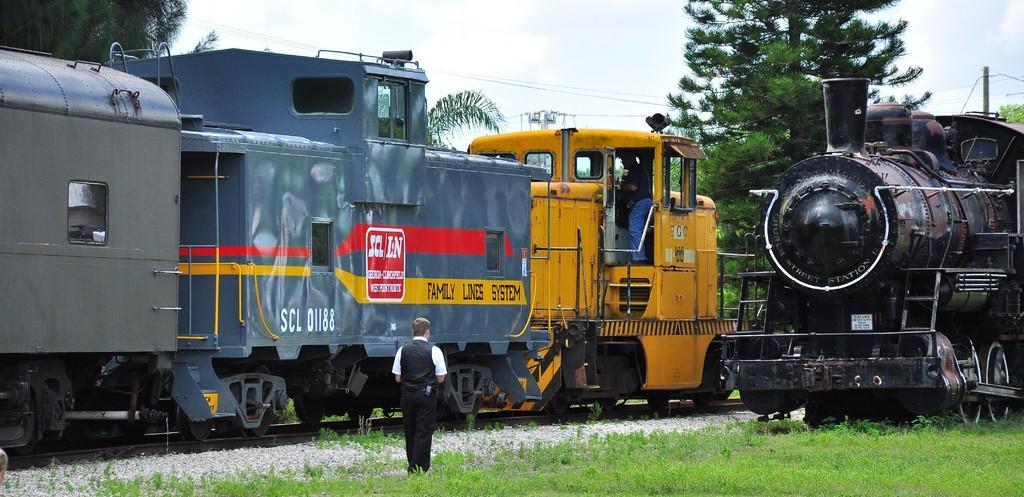Can you describe this image briefly? In this image we can see the trains on the track. We can also see a person standing inside the train. On the bottom of the image we can see some stones, grass and a person standing. We can also see some poles with wires, trees and the sky which looks cloudy. 